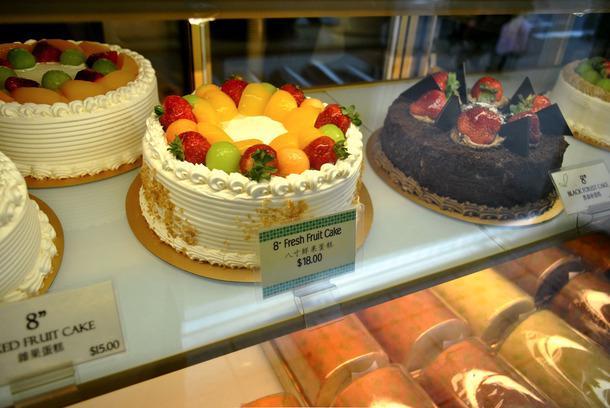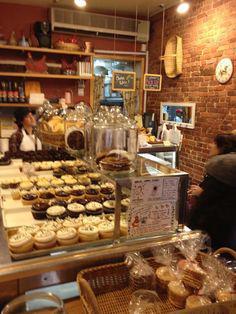The first image is the image on the left, the second image is the image on the right. Given the left and right images, does the statement "The left image shows decorated cakes on at least the top row of a glass case, and the decorations include upright chocolate shapes." hold true? Answer yes or no. Yes. The first image is the image on the left, the second image is the image on the right. For the images displayed, is the sentence "Some items are wrapped in clear plastic." factually correct? Answer yes or no. Yes. 